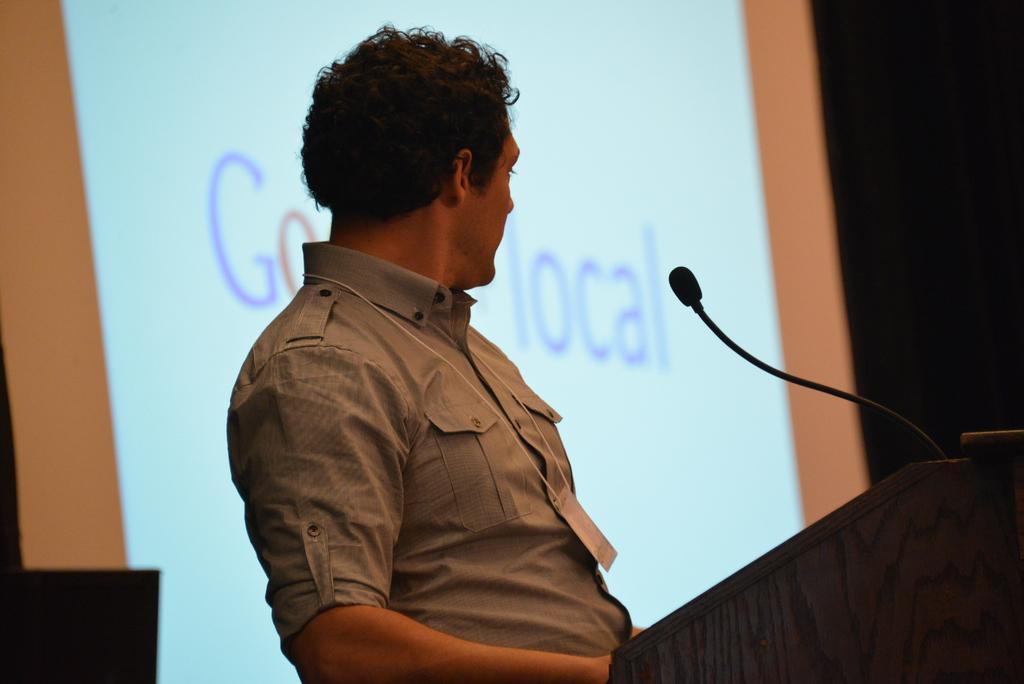Can you describe this image briefly? In the image we can see a man standing and wearing clothes. This is a podium and microphone and a projected screen. 